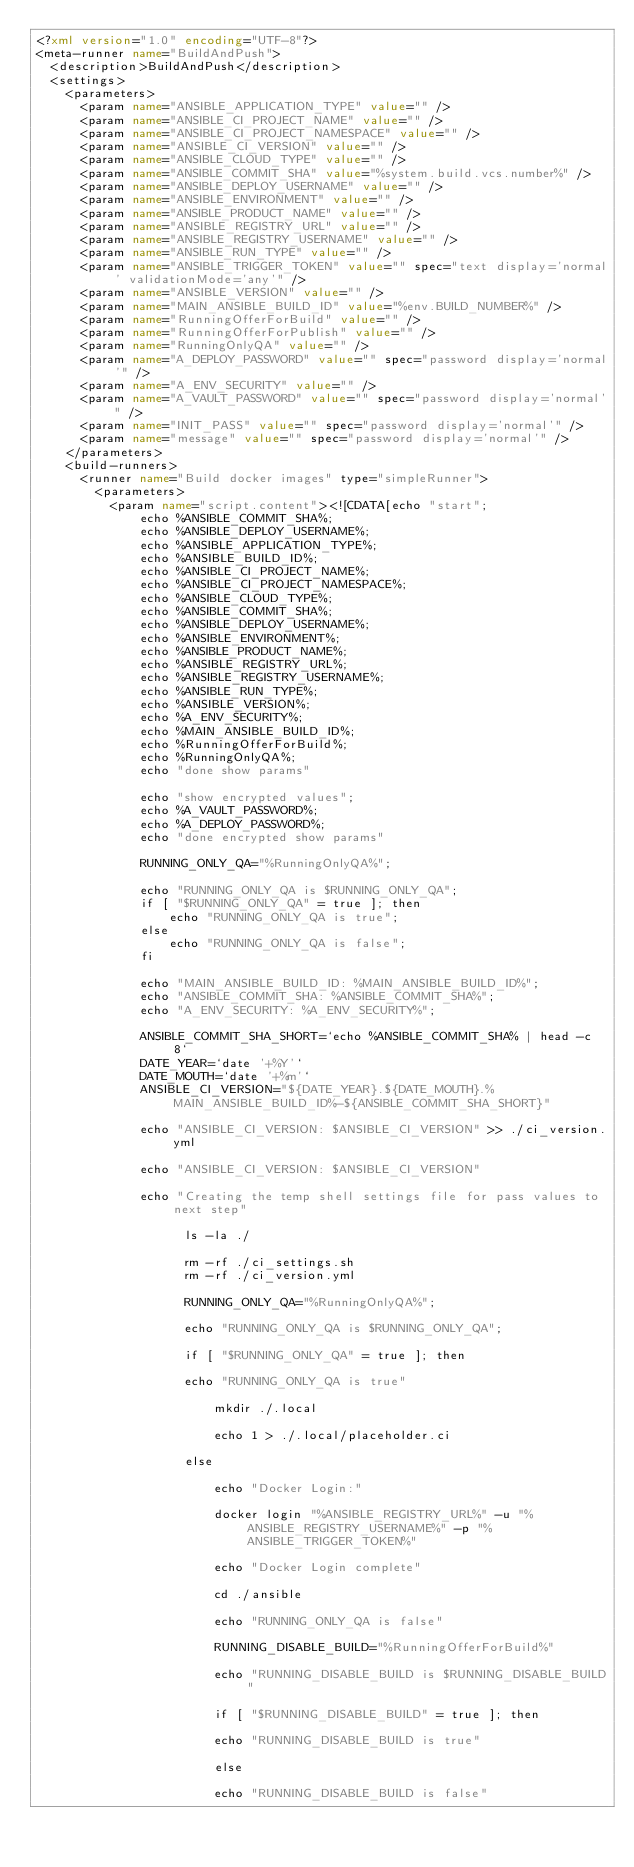<code> <loc_0><loc_0><loc_500><loc_500><_XML_><?xml version="1.0" encoding="UTF-8"?>
<meta-runner name="BuildAndPush">
  <description>BuildAndPush</description>
  <settings>
    <parameters>
      <param name="ANSIBLE_APPLICATION_TYPE" value="" />
      <param name="ANSIBLE_CI_PROJECT_NAME" value="" />
      <param name="ANSIBLE_CI_PROJECT_NAMESPACE" value="" />
      <param name="ANSIBLE_CI_VERSION" value="" />
      <param name="ANSIBLE_CLOUD_TYPE" value="" />
      <param name="ANSIBLE_COMMIT_SHA" value="%system.build.vcs.number%" />
      <param name="ANSIBLE_DEPLOY_USERNAME" value="" />
      <param name="ANSIBLE_ENVIRONMENT" value="" />
      <param name="ANSIBLE_PRODUCT_NAME" value="" />
      <param name="ANSIBLE_REGISTRY_URL" value="" />
      <param name="ANSIBLE_REGISTRY_USERNAME" value="" />
      <param name="ANSIBLE_RUN_TYPE" value="" />
      <param name="ANSIBLE_TRIGGER_TOKEN" value="" spec="text display='normal' validationMode='any'" />
      <param name="ANSIBLE_VERSION" value="" />
      <param name="MAIN_ANSIBLE_BUILD_ID" value="%env.BUILD_NUMBER%" />
      <param name="RunningOfferForBuild" value="" />
      <param name="RunningOfferForPublish" value="" />
      <param name="RunningOnlyQA" value="" />
      <param name="A_DEPLOY_PASSWORD" value="" spec="password display='normal'" />
      <param name="A_ENV_SECURITY" value="" />
      <param name="A_VAULT_PASSWORD" value="" spec="password display='normal'" />
      <param name="INIT_PASS" value="" spec="password display='normal'" />
      <param name="message" value="" spec="password display='normal'" />
    </parameters>
    <build-runners>
      <runner name="Build docker images" type="simpleRunner">
        <parameters>
          <param name="script.content"><![CDATA[echo "start";
              echo %ANSIBLE_COMMIT_SHA%;
              echo %ANSIBLE_DEPLOY_USERNAME%;
              echo %ANSIBLE_APPLICATION_TYPE%;
              echo %ANSIBLE_BUILD_ID%;
              echo %ANSIBLE_CI_PROJECT_NAME%;
              echo %ANSIBLE_CI_PROJECT_NAMESPACE%;
              echo %ANSIBLE_CLOUD_TYPE%;
              echo %ANSIBLE_COMMIT_SHA%;
              echo %ANSIBLE_DEPLOY_USERNAME%;
              echo %ANSIBLE_ENVIRONMENT%;
              echo %ANSIBLE_PRODUCT_NAME%;
              echo %ANSIBLE_REGISTRY_URL%;
              echo %ANSIBLE_REGISTRY_USERNAME%;
              echo %ANSIBLE_RUN_TYPE%;
              echo %ANSIBLE_VERSION%;
              echo %A_ENV_SECURITY%;
              echo %MAIN_ANSIBLE_BUILD_ID%;
              echo %RunningOfferForBuild%;
              echo %RunningOnlyQA%;
              echo "done show params"

              echo "show encrypted values";
              echo %A_VAULT_PASSWORD%;
              echo %A_DEPLOY_PASSWORD%;
              echo "done encrypted show params"

              RUNNING_ONLY_QA="%RunningOnlyQA%";

              echo "RUNNING_ONLY_QA is $RUNNING_ONLY_QA";
              if [ "$RUNNING_ONLY_QA" = true ]; then
                  echo "RUNNING_ONLY_QA is true";
              else
                  echo "RUNNING_ONLY_QA is false";
              fi

              echo "MAIN_ANSIBLE_BUILD_ID: %MAIN_ANSIBLE_BUILD_ID%";
              echo "ANSIBLE_COMMIT_SHA: %ANSIBLE_COMMIT_SHA%";
              echo "A_ENV_SECURITY: %A_ENV_SECURITY%";

              ANSIBLE_COMMIT_SHA_SHORT=`echo %ANSIBLE_COMMIT_SHA% | head -c 8`
              DATE_YEAR=`date '+%Y'`
              DATE_MOUTH=`date '+%m'`
              ANSIBLE_CI_VERSION="${DATE_YEAR}.${DATE_MOUTH}.%MAIN_ANSIBLE_BUILD_ID%-${ANSIBLE_COMMIT_SHA_SHORT}"

              echo "ANSIBLE_CI_VERSION: $ANSIBLE_CI_VERSION" >> ./ci_version.yml

			  echo "ANSIBLE_CI_VERSION: $ANSIBLE_CI_VERSION"

              echo "Creating the temp shell settings file for pass values to next step"

                    ls -la ./

                    rm -rf ./ci_settings.sh
                    rm -rf ./ci_version.yml

                    RUNNING_ONLY_QA="%RunningOnlyQA%";

                    echo "RUNNING_ONLY_QA is $RUNNING_ONLY_QA";

                    if [ "$RUNNING_ONLY_QA" = true ]; then

                    echo "RUNNING_ONLY_QA is true"

                    	mkdir ./.local

                    	echo 1 > ./.local/placeholder.ci

                    else

                        echo "Docker Login:"

                        docker login "%ANSIBLE_REGISTRY_URL%" -u "%ANSIBLE_REGISTRY_USERNAME%" -p "%ANSIBLE_TRIGGER_TOKEN%"

                        echo "Docker Login complete"

                        cd ./ansible
                        
                        echo "RUNNING_ONLY_QA is false"

                        RUNNING_DISABLE_BUILD="%RunningOfferForBuild%"

                        echo "RUNNING_DISABLE_BUILD is $RUNNING_DISABLE_BUILD"

                        if [ "$RUNNING_DISABLE_BUILD" = true ]; then
                        
                        echo "RUNNING_DISABLE_BUILD is true"

                        else
                        
                        echo "RUNNING_DISABLE_BUILD is false"
                        </code> 